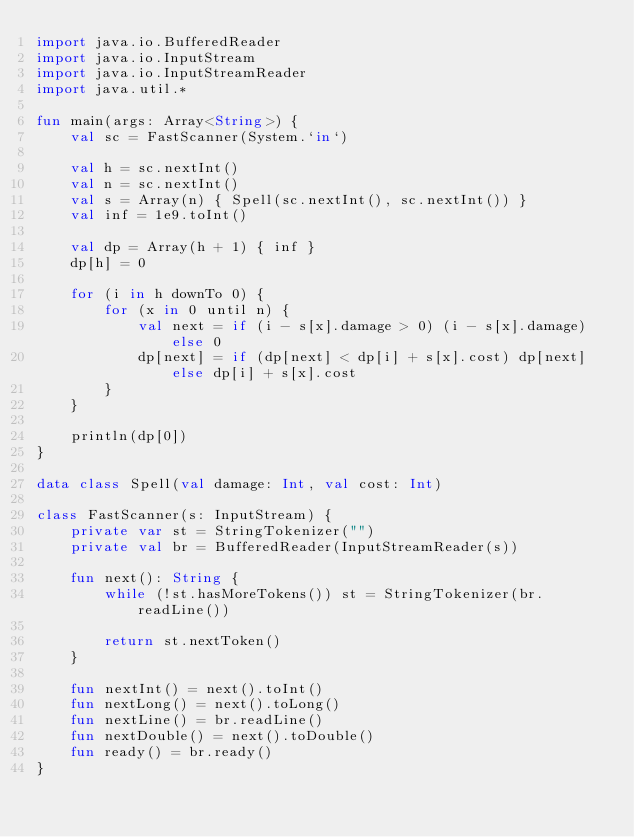Convert code to text. <code><loc_0><loc_0><loc_500><loc_500><_Kotlin_>import java.io.BufferedReader
import java.io.InputStream
import java.io.InputStreamReader
import java.util.*

fun main(args: Array<String>) {
    val sc = FastScanner(System.`in`)

    val h = sc.nextInt()
    val n = sc.nextInt()
    val s = Array(n) { Spell(sc.nextInt(), sc.nextInt()) }
    val inf = 1e9.toInt()

    val dp = Array(h + 1) { inf }
    dp[h] = 0

    for (i in h downTo 0) {
        for (x in 0 until n) {
            val next = if (i - s[x].damage > 0) (i - s[x].damage) else 0 
            dp[next] = if (dp[next] < dp[i] + s[x].cost) dp[next] else dp[i] + s[x].cost 
        }
    }

    println(dp[0])
}

data class Spell(val damage: Int, val cost: Int)

class FastScanner(s: InputStream) {
    private var st = StringTokenizer("")
    private val br = BufferedReader(InputStreamReader(s))

    fun next(): String {
        while (!st.hasMoreTokens()) st = StringTokenizer(br.readLine())

        return st.nextToken()
    }

    fun nextInt() = next().toInt()
    fun nextLong() = next().toLong()
    fun nextLine() = br.readLine()
    fun nextDouble() = next().toDouble()
    fun ready() = br.ready()
}</code> 